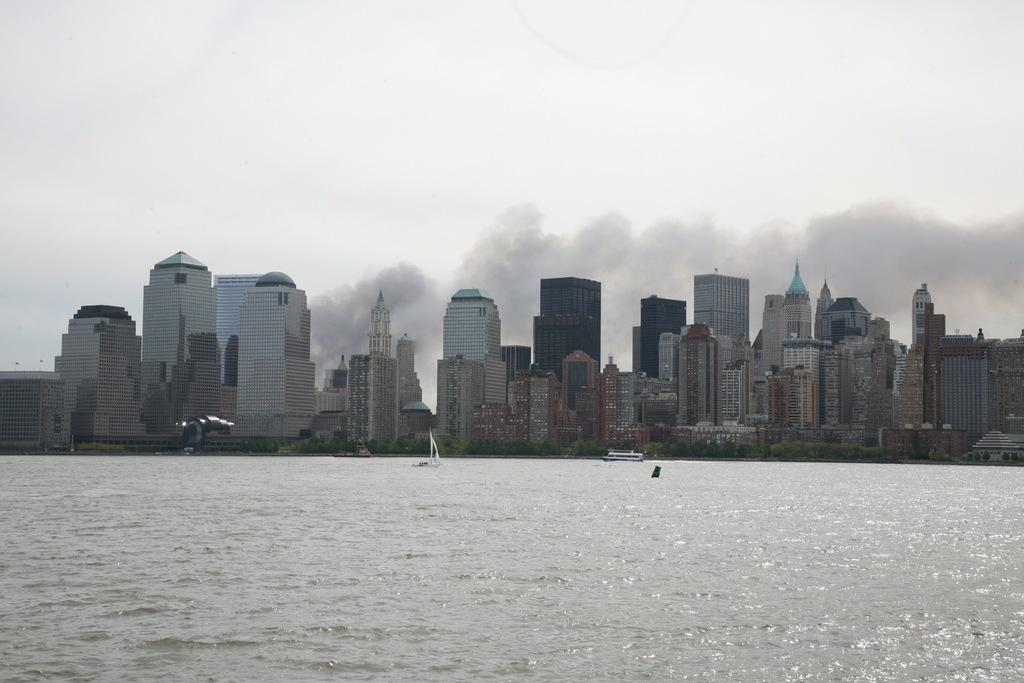What is at the bottom of the image? There is water at the bottom of the image. What can be seen in the middle of the image? There are buildings in the middle of the image. What is visible at the top of the image? The sky is visible at the top of the image. What type of cakes are being smoked on someone's wrist in the image? There are no cakes, smoke, or wrists present in the image. 